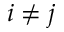<formula> <loc_0><loc_0><loc_500><loc_500>i \neq j</formula> 